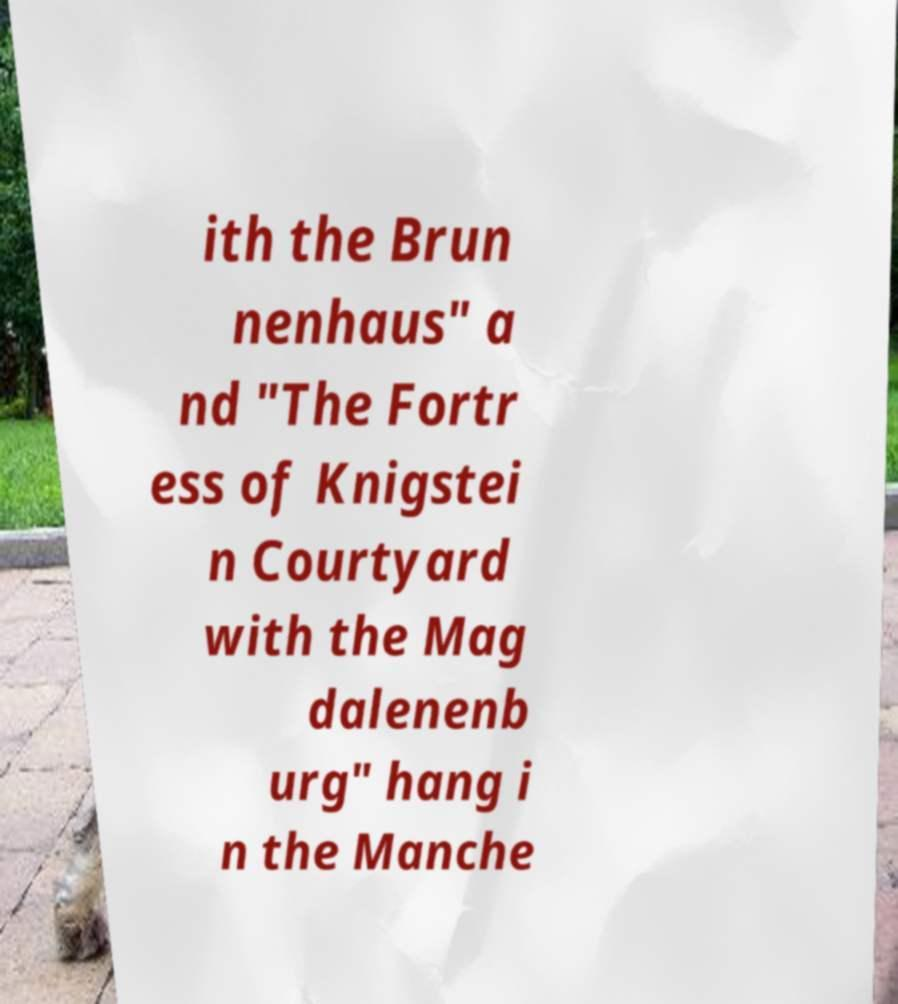There's text embedded in this image that I need extracted. Can you transcribe it verbatim? ith the Brun nenhaus" a nd "The Fortr ess of Knigstei n Courtyard with the Mag dalenenb urg" hang i n the Manche 